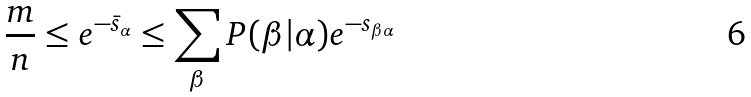Convert formula to latex. <formula><loc_0><loc_0><loc_500><loc_500>\frac { m } { n } \leq e ^ { - \bar { s } _ { \alpha } } \leq \sum _ { \beta } P ( \beta | \alpha ) e ^ { - s _ { \beta \alpha } }</formula> 